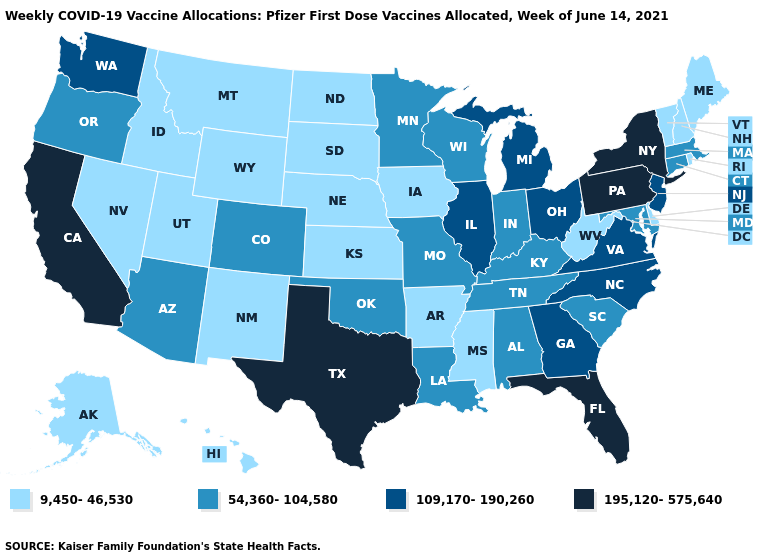What is the highest value in the Northeast ?
Write a very short answer. 195,120-575,640. Which states have the lowest value in the MidWest?
Write a very short answer. Iowa, Kansas, Nebraska, North Dakota, South Dakota. What is the value of Kansas?
Be succinct. 9,450-46,530. Which states hav the highest value in the West?
Concise answer only. California. What is the value of New Jersey?
Keep it brief. 109,170-190,260. Name the states that have a value in the range 109,170-190,260?
Be succinct. Georgia, Illinois, Michigan, New Jersey, North Carolina, Ohio, Virginia, Washington. Which states hav the highest value in the MidWest?
Quick response, please. Illinois, Michigan, Ohio. What is the value of South Carolina?
Keep it brief. 54,360-104,580. What is the value of Hawaii?
Keep it brief. 9,450-46,530. Is the legend a continuous bar?
Quick response, please. No. Which states hav the highest value in the South?
Write a very short answer. Florida, Texas. Does Arkansas have the lowest value in the USA?
Be succinct. Yes. What is the value of South Carolina?
Write a very short answer. 54,360-104,580. What is the value of Idaho?
Quick response, please. 9,450-46,530. Which states have the highest value in the USA?
Answer briefly. California, Florida, New York, Pennsylvania, Texas. 